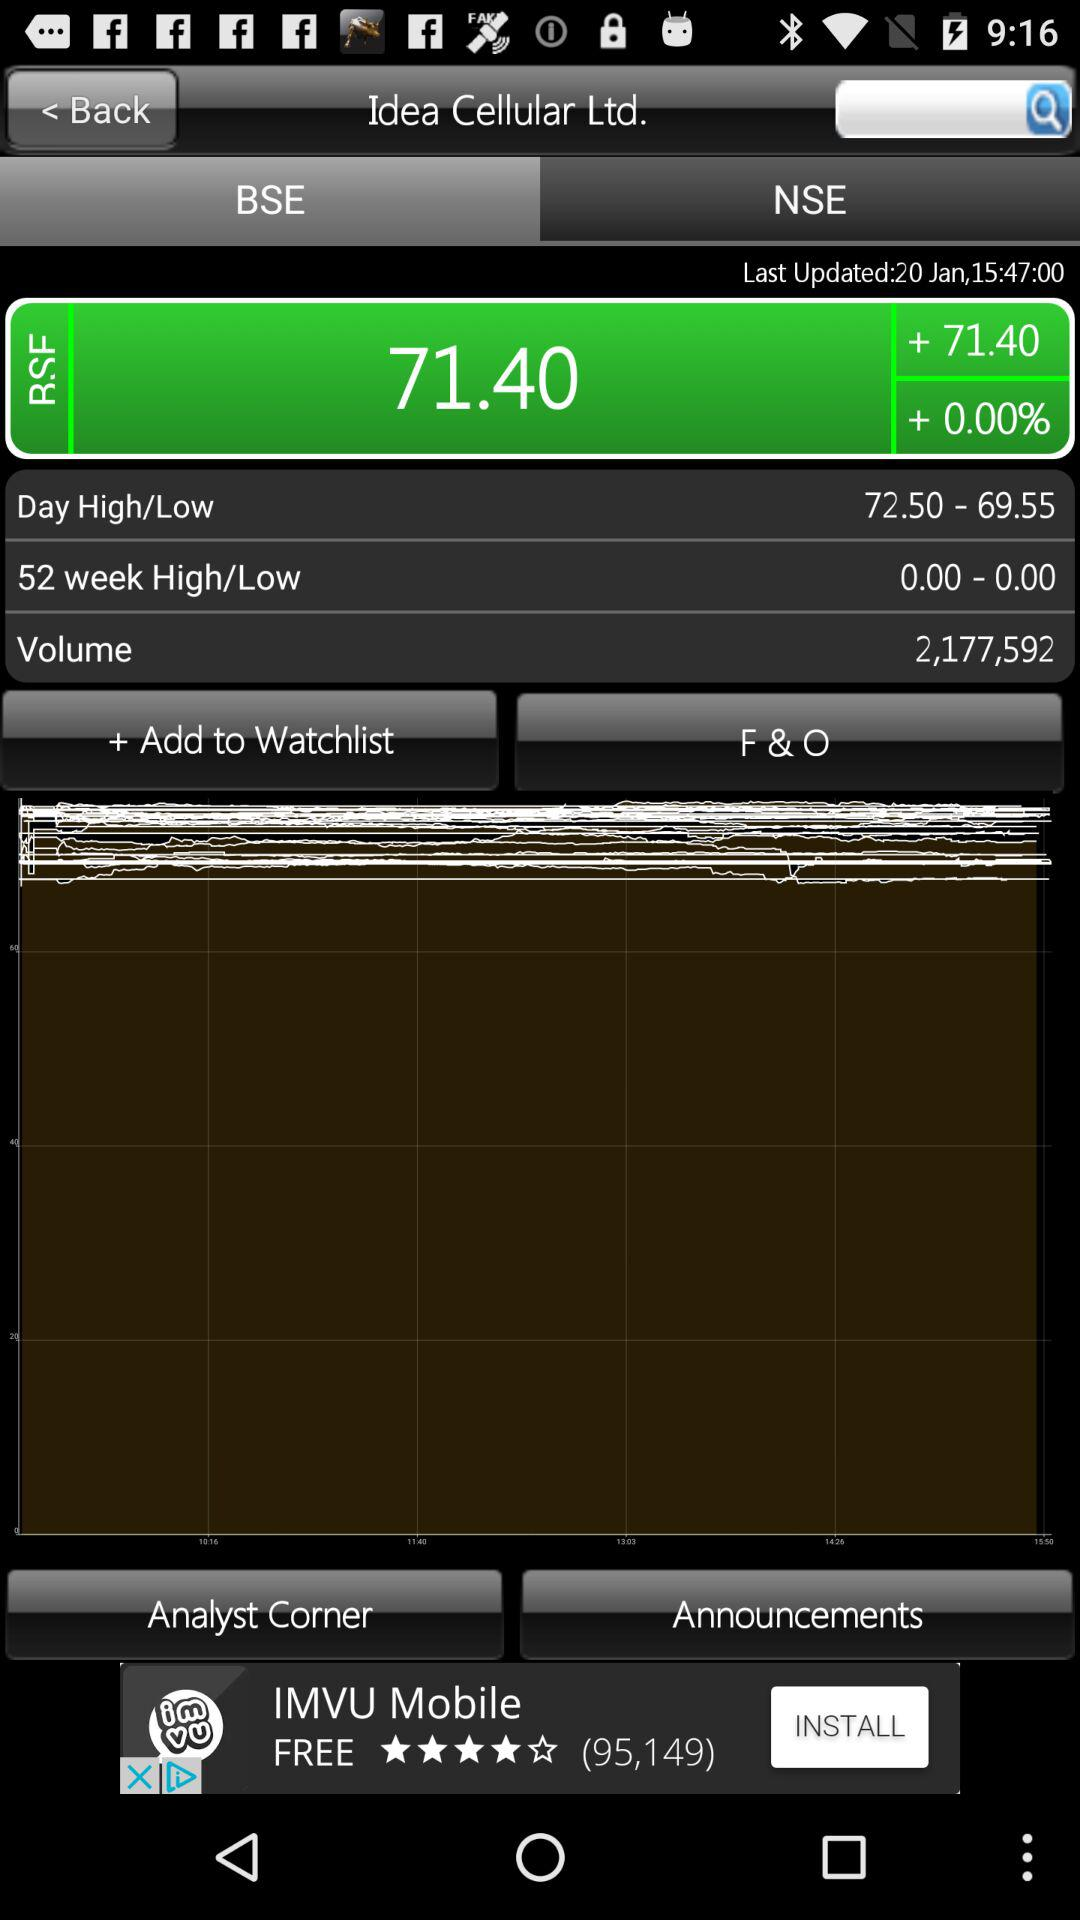What is the given range for "Day High/Low"? The given range is from 72.50 to 69.55. 